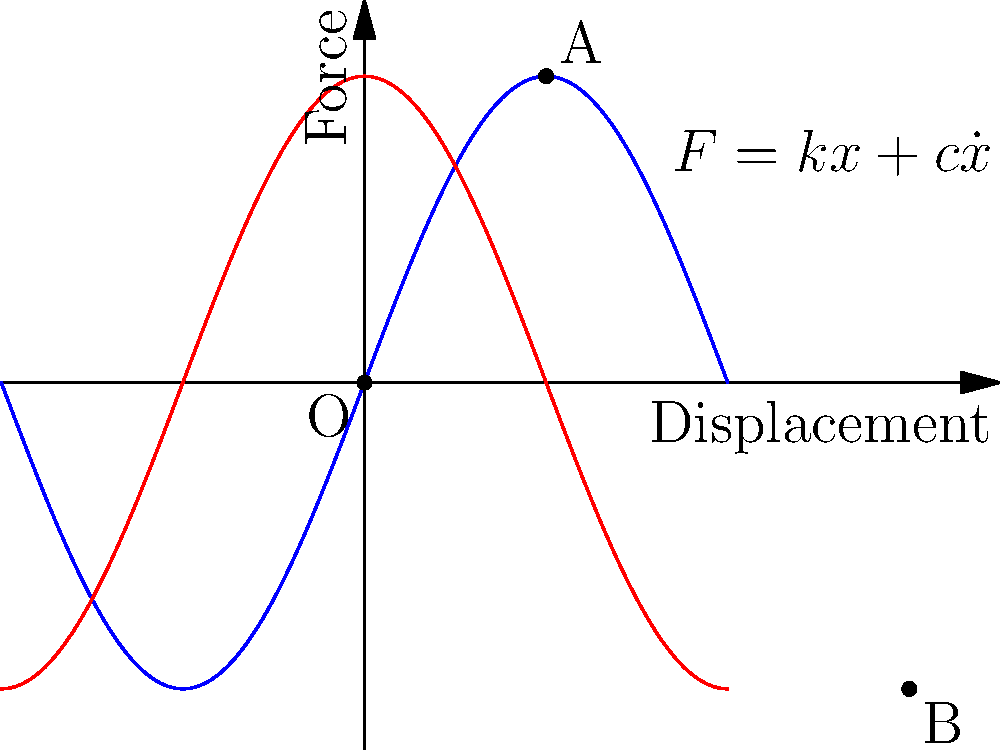In the force-displacement curve of a spring-mass-damper system under harmonic excitation shown above, what does the area enclosed by the curve represent, and how does it relate to the system's energy? To understand the significance of the area enclosed by the force-displacement curve, let's follow these steps:

1. The curve shown is a hysteresis loop, typical for a spring-mass-damper system under harmonic excitation.

2. The equation $F=kx+c\dot{x}$ represents the force in the system, where:
   - $k$ is the spring constant
   - $x$ is the displacement
   - $c$ is the damping coefficient
   - $\dot{x}$ is the velocity

3. The area enclosed by the curve represents the energy dissipated per cycle of oscillation.

4. This energy dissipation occurs due to the damping in the system, represented by the term $c\dot{x}$ in the equation.

5. The work done by the damping force over one cycle is:

   $W = \oint F dx = \oint (kx + c\dot{x}) dx$

6. The spring force ($kx$) is conservative and doesn't contribute to net work over a complete cycle. Therefore:

   $W = \oint c\dot{x} dx$

7. This integral is exactly the area enclosed by the force-displacement curve.

8. The larger the enclosed area, the more energy is dissipated per cycle, indicating stronger damping in the system.

9. In terms of the system's energy, this dissipation represents the conversion of mechanical energy (kinetic and potential) into heat energy due to damping effects.

10. The shape of the curve (clockwise direction) indicates that work is being done on the system during the loading phase (top half) and by the system during the unloading phase (bottom half).
Answer: Energy dissipated per cycle due to damping 